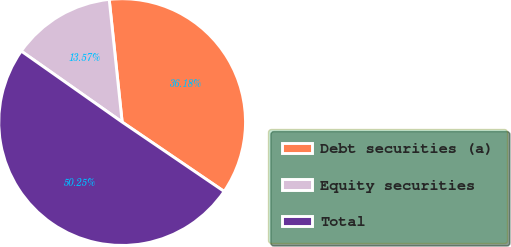<chart> <loc_0><loc_0><loc_500><loc_500><pie_chart><fcel>Debt securities (a)<fcel>Equity securities<fcel>Total<nl><fcel>36.18%<fcel>13.57%<fcel>50.25%<nl></chart> 